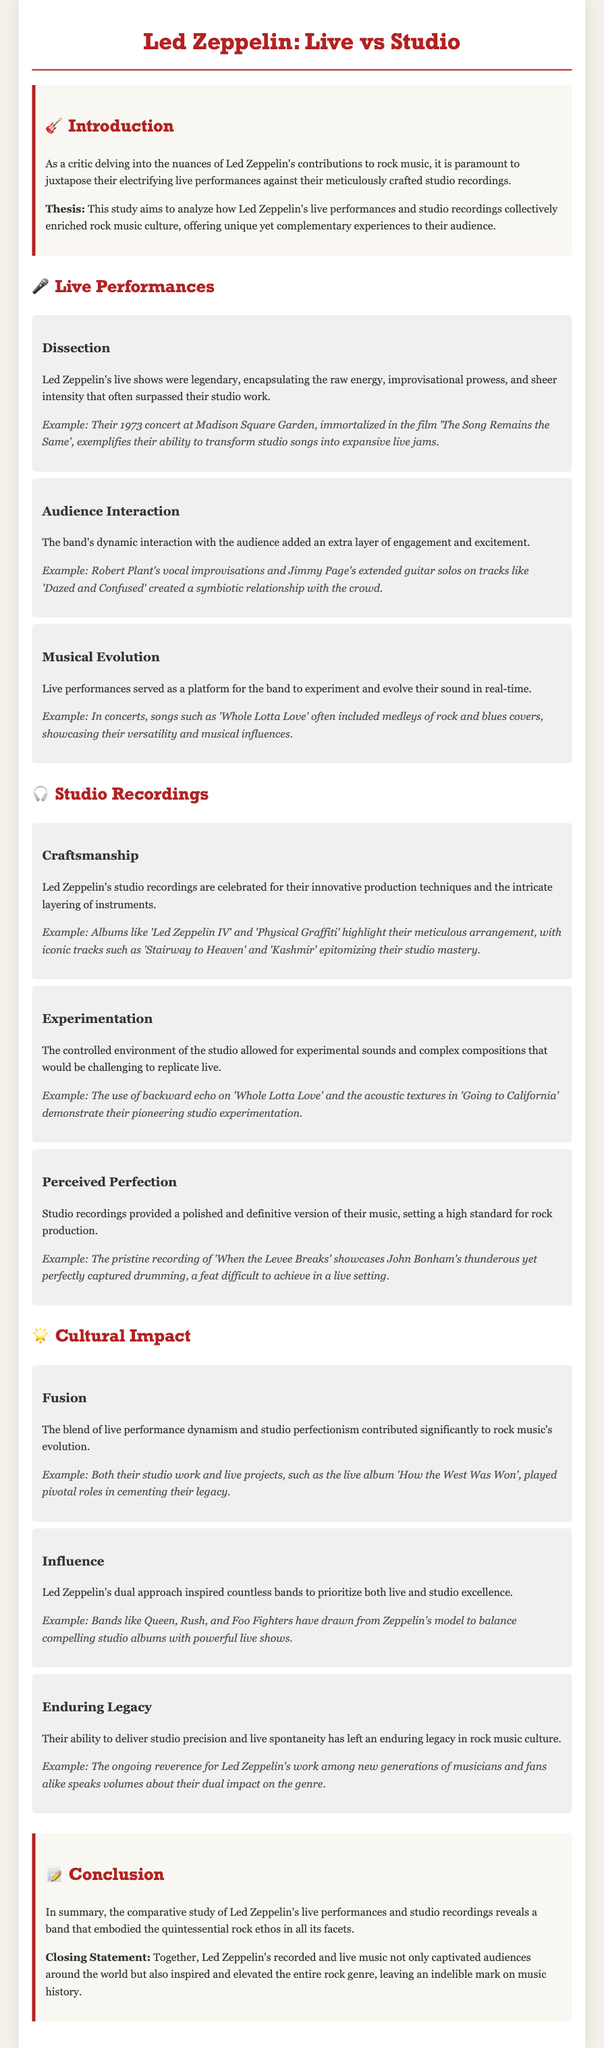What year was the concert at Madison Square Garden? The year of the concert at Madison Square Garden, referenced in the context of their live performances, is 1973.
Answer: 1973 What are the names of two albums highlighted for their craftsmanship? The two albums emphasized for their innovative production techniques in studio recordings are 'Led Zeppelin IV' and 'Physical Graffiti'.
Answer: 'Led Zeppelin IV' and 'Physical Graffiti' Which song featured the use of backward echo? The song that demonstrated pioneering studio experimentation with backward echo is 'Whole Lotta Love'.
Answer: 'Whole Lotta Love' What is the thesis of the study? The thesis of the study articulates that Led Zeppelin's live performances and studio recordings collectively enriched rock music culture.
Answer: They collectively enriched rock music culture Which song is an example of Robert Plant's vocal improvisations during live performances? The example provided for Robert Plant's vocal improvisations during live performances is 'Dazed and Confused'.
Answer: 'Dazed and Confused' What form of musical experience did their live performances provide? Their live performances offered a raw energy and improvisational prowess that often surpassed their studio work.
Answer: Raw energy and improvisational prowess What influence did Led Zeppelin's approach have on other bands? Led Zeppelin's dual approach inspired bands to prioritize both live and studio excellence.
Answer: Both live and studio excellence In what year was the live album 'How the West Was Won' released? The document does not specify the year for 'How the West Was Won', so this question should focus on its thematic impact in the context of their live work rather than a specific date.
Answer: N/A 